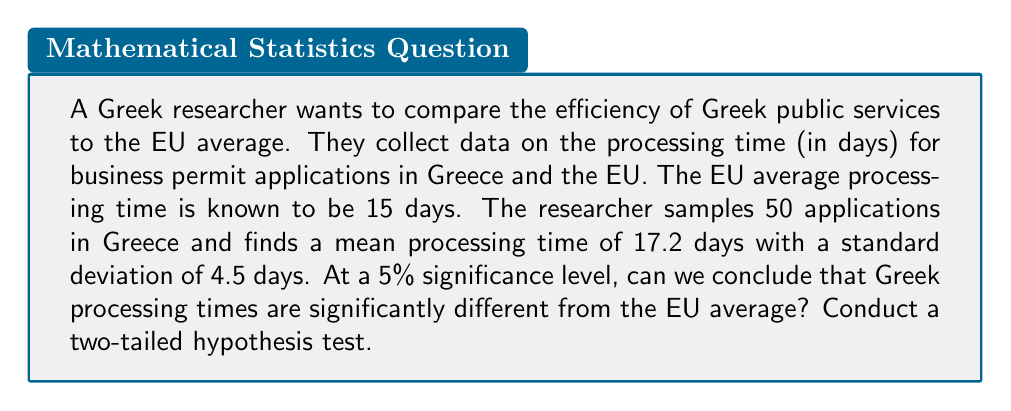What is the answer to this math problem? 1. Set up the hypotheses:
   $H_0: \mu = 15$ (Greek processing time equals EU average)
   $H_a: \mu \neq 15$ (Greek processing time differs from EU average)

2. Choose significance level: $\alpha = 0.05$

3. Calculate the test statistic:
   $t = \frac{\bar{x} - \mu_0}{s/\sqrt{n}}$
   Where:
   $\bar{x} = 17.2$ (sample mean)
   $\mu_0 = 15$ (hypothesized population mean)
   $s = 4.5$ (sample standard deviation)
   $n = 50$ (sample size)

   $t = \frac{17.2 - 15}{4.5/\sqrt{50}} = \frac{2.2}{0.6364} = 3.4572$

4. Determine critical values:
   For a two-tailed test with $\alpha = 0.05$ and $df = 49$, 
   $t_{critical} = \pm 2.0096$

5. Compare test statistic to critical values:
   $|3.4572| > 2.0096$

6. Calculate p-value:
   $p = 2 \times P(T > |3.4572|) \approx 0.0011$

7. Decision:
   Since $|t| > t_{critical}$ and $p < \alpha$, reject $H_0$.
Answer: Reject $H_0$. Greek processing times significantly differ from EU average (p = 0.0011). 